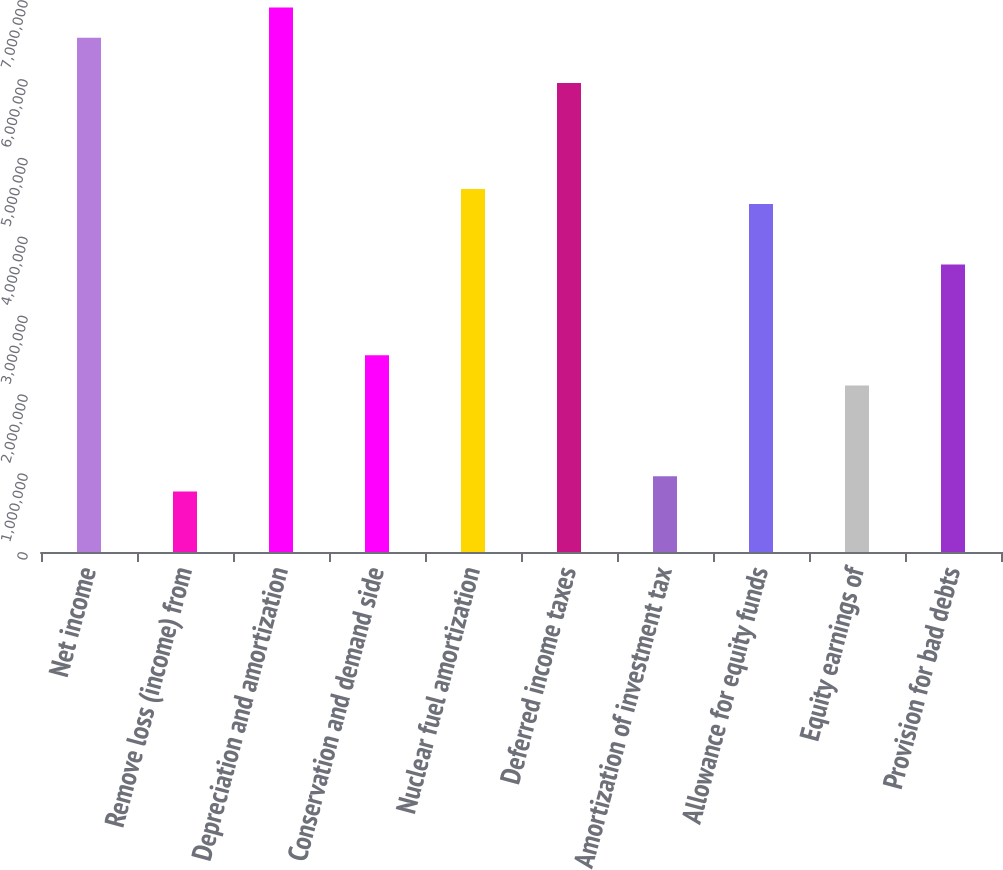Convert chart. <chart><loc_0><loc_0><loc_500><loc_500><bar_chart><fcel>Net income<fcel>Remove loss (income) from<fcel>Depreciation and amortization<fcel>Conservation and demand side<fcel>Nuclear fuel amortization<fcel>Deferred income taxes<fcel>Amortization of investment tax<fcel>Allowance for equity funds<fcel>Equity earnings of<fcel>Provision for bad debts<nl><fcel>6.52214e+06<fcel>767544<fcel>6.90578e+06<fcel>2.49392e+06<fcel>4.60394e+06<fcel>5.94668e+06<fcel>959364<fcel>4.41212e+06<fcel>2.11028e+06<fcel>3.64484e+06<nl></chart> 